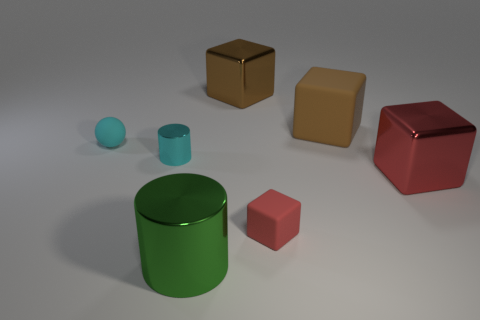Subtract all gray spheres. Subtract all green blocks. How many spheres are left? 1 Subtract all gray cubes. How many purple cylinders are left? 0 Add 3 tiny grays. How many big things exist? 0 Subtract all big blue matte spheres. Subtract all small things. How many objects are left? 4 Add 3 big cylinders. How many big cylinders are left? 4 Add 3 large brown rubber blocks. How many large brown rubber blocks exist? 4 Add 3 brown matte things. How many objects exist? 10 Subtract all cyan cylinders. How many cylinders are left? 1 Subtract all large cubes. How many cubes are left? 1 Subtract 0 purple spheres. How many objects are left? 7 